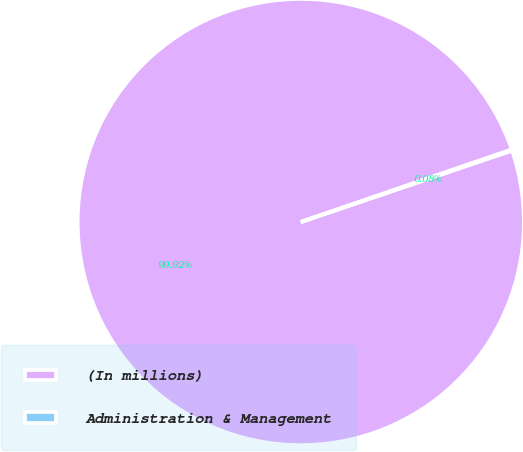Convert chart to OTSL. <chart><loc_0><loc_0><loc_500><loc_500><pie_chart><fcel>(In millions)<fcel>Administration & Management<nl><fcel>99.92%<fcel>0.08%<nl></chart> 